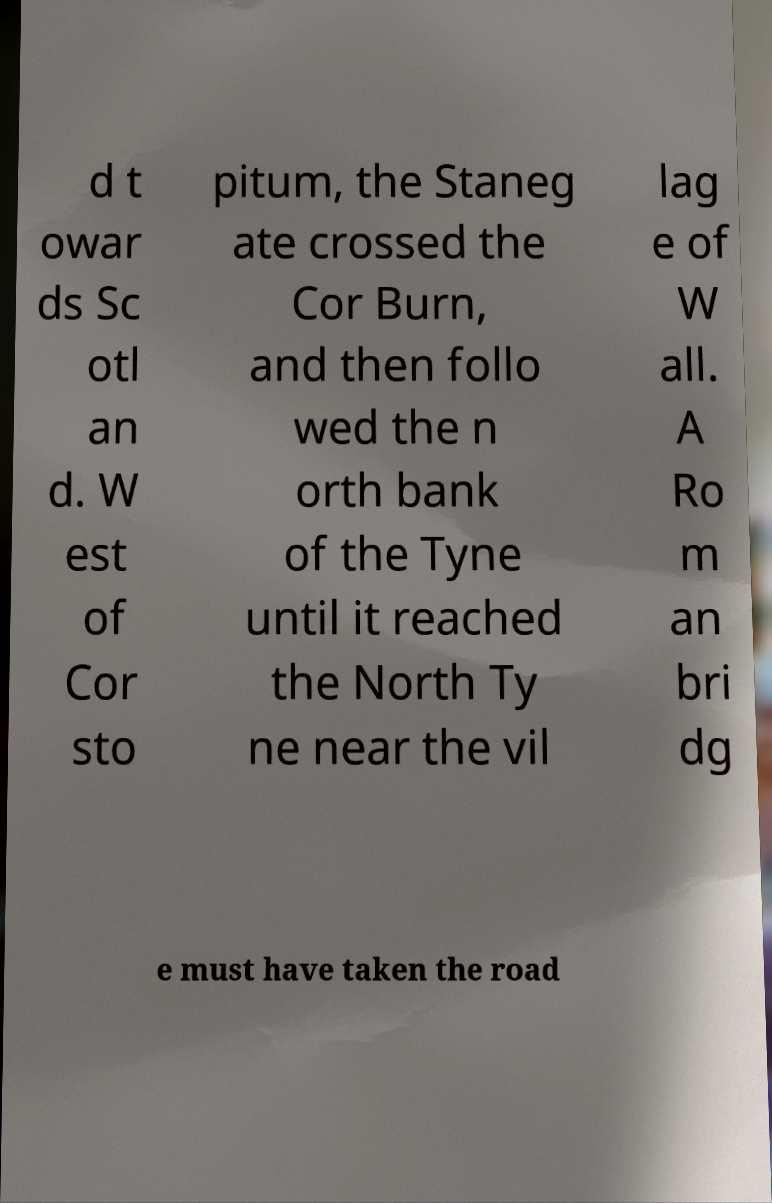Please identify and transcribe the text found in this image. d t owar ds Sc otl an d. W est of Cor sto pitum, the Staneg ate crossed the Cor Burn, and then follo wed the n orth bank of the Tyne until it reached the North Ty ne near the vil lag e of W all. A Ro m an bri dg e must have taken the road 